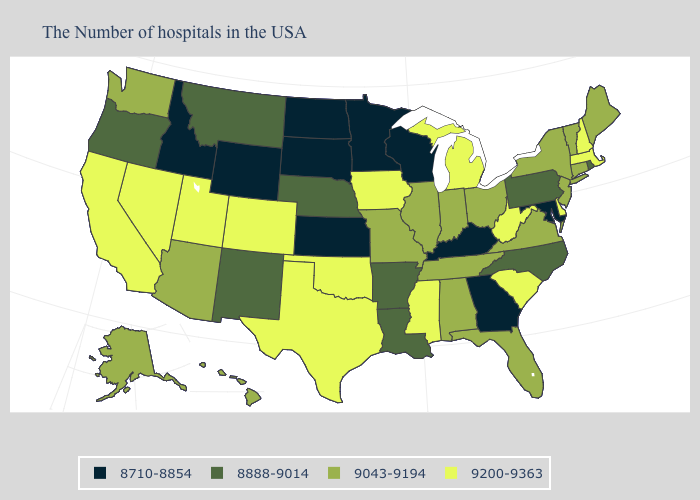What is the value of Maine?
Be succinct. 9043-9194. Among the states that border Maine , which have the highest value?
Short answer required. New Hampshire. What is the highest value in states that border North Carolina?
Give a very brief answer. 9200-9363. Which states have the highest value in the USA?
Be succinct. Massachusetts, New Hampshire, Delaware, South Carolina, West Virginia, Michigan, Mississippi, Iowa, Oklahoma, Texas, Colorado, Utah, Nevada, California. What is the highest value in the USA?
Be succinct. 9200-9363. Is the legend a continuous bar?
Short answer required. No. Name the states that have a value in the range 9043-9194?
Write a very short answer. Maine, Vermont, Connecticut, New York, New Jersey, Virginia, Ohio, Florida, Indiana, Alabama, Tennessee, Illinois, Missouri, Arizona, Washington, Alaska, Hawaii. What is the value of Colorado?
Short answer required. 9200-9363. Which states have the lowest value in the USA?
Answer briefly. Maryland, Georgia, Kentucky, Wisconsin, Minnesota, Kansas, South Dakota, North Dakota, Wyoming, Idaho. Does Vermont have the same value as Virginia?
Be succinct. Yes. Among the states that border Maryland , does Delaware have the lowest value?
Give a very brief answer. No. What is the value of Maryland?
Quick response, please. 8710-8854. What is the lowest value in states that border Rhode Island?
Answer briefly. 9043-9194. Which states have the highest value in the USA?
Quick response, please. Massachusetts, New Hampshire, Delaware, South Carolina, West Virginia, Michigan, Mississippi, Iowa, Oklahoma, Texas, Colorado, Utah, Nevada, California. Among the states that border Virginia , does West Virginia have the highest value?
Give a very brief answer. Yes. 